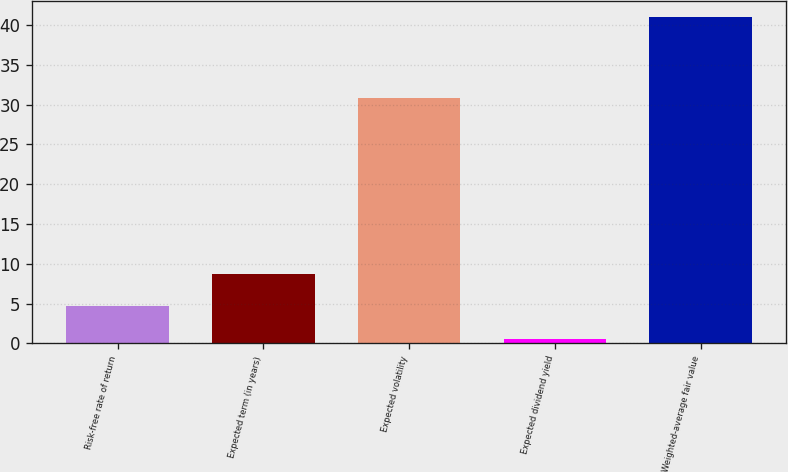Convert chart. <chart><loc_0><loc_0><loc_500><loc_500><bar_chart><fcel>Risk-free rate of return<fcel>Expected term (in years)<fcel>Expected volatility<fcel>Expected dividend yield<fcel>Weighted-average fair value<nl><fcel>4.64<fcel>8.68<fcel>30.9<fcel>0.6<fcel>41.03<nl></chart> 